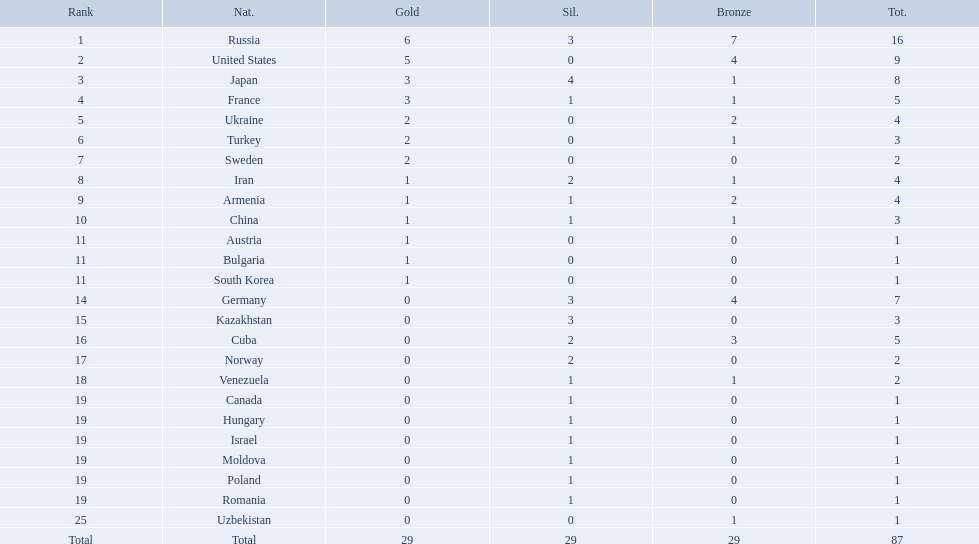Which nations participated in the 1995 world wrestling championships? Russia, United States, Japan, France, Ukraine, Turkey, Sweden, Iran, Armenia, China, Austria, Bulgaria, South Korea, Germany, Kazakhstan, Cuba, Norway, Venezuela, Canada, Hungary, Israel, Moldova, Poland, Romania, Uzbekistan. And between iran and germany, which one placed in the top 10? Germany. How many gold medals did the united states win? 5. Who won more than 5 gold medals? Russia. What were the nations that participated in the 1995 world wrestling championships? Russia, United States, Japan, France, Ukraine, Turkey, Sweden, Iran, Armenia, China, Austria, Bulgaria, South Korea, Germany, Kazakhstan, Cuba, Norway, Venezuela, Canada, Hungary, Israel, Moldova, Poland, Romania, Uzbekistan. How many gold medals did the united states earn in the championship? 5. What amount of medals earner was greater than this value? 6. What country earned these medals? Russia. Which nations are there? Russia, 6, United States, 5, Japan, 3, France, 3, Ukraine, 2, Turkey, 2, Sweden, 2, Iran, 1, Armenia, 1, China, 1, Austria, 1, Bulgaria, 1, South Korea, 1, Germany, 0, Kazakhstan, 0, Cuba, 0, Norway, 0, Venezuela, 0, Canada, 0, Hungary, 0, Israel, 0, Moldova, 0, Poland, 0, Romania, 0, Uzbekistan, 0. Which nations won gold? Russia, 6, United States, 5, Japan, 3, France, 3, Ukraine, 2, Turkey, 2, Sweden, 2, Iran, 1, Armenia, 1, China, 1, Austria, 1, Bulgaria, 1, South Korea, 1. How many golds did united states win? United States, 5. Which country has more than 5 gold medals? Russia, 6. What country is it? Russia. Parse the full table in json format. {'header': ['Rank', 'Nat.', 'Gold', 'Sil.', 'Bronze', 'Tot.'], 'rows': [['1', 'Russia', '6', '3', '7', '16'], ['2', 'United States', '5', '0', '4', '9'], ['3', 'Japan', '3', '4', '1', '8'], ['4', 'France', '3', '1', '1', '5'], ['5', 'Ukraine', '2', '0', '2', '4'], ['6', 'Turkey', '2', '0', '1', '3'], ['7', 'Sweden', '2', '0', '0', '2'], ['8', 'Iran', '1', '2', '1', '4'], ['9', 'Armenia', '1', '1', '2', '4'], ['10', 'China', '1', '1', '1', '3'], ['11', 'Austria', '1', '0', '0', '1'], ['11', 'Bulgaria', '1', '0', '0', '1'], ['11', 'South Korea', '1', '0', '0', '1'], ['14', 'Germany', '0', '3', '4', '7'], ['15', 'Kazakhstan', '0', '3', '0', '3'], ['16', 'Cuba', '0', '2', '3', '5'], ['17', 'Norway', '0', '2', '0', '2'], ['18', 'Venezuela', '0', '1', '1', '2'], ['19', 'Canada', '0', '1', '0', '1'], ['19', 'Hungary', '0', '1', '0', '1'], ['19', 'Israel', '0', '1', '0', '1'], ['19', 'Moldova', '0', '1', '0', '1'], ['19', 'Poland', '0', '1', '0', '1'], ['19', 'Romania', '0', '1', '0', '1'], ['25', 'Uzbekistan', '0', '0', '1', '1'], ['Total', 'Total', '29', '29', '29', '87']]} What nations have one gold medal? Iran, Armenia, China, Austria, Bulgaria, South Korea. Of these, which nations have zero silver medals? Austria, Bulgaria, South Korea. Of these, which nations also have zero bronze medals? Austria. Which nations only won less then 5 medals? Ukraine, Turkey, Sweden, Iran, Armenia, China, Austria, Bulgaria, South Korea, Germany, Kazakhstan, Norway, Venezuela, Canada, Hungary, Israel, Moldova, Poland, Romania, Uzbekistan. Which of these were not asian nations? Ukraine, Turkey, Sweden, Iran, Armenia, Austria, Bulgaria, Germany, Kazakhstan, Norway, Venezuela, Canada, Hungary, Israel, Moldova, Poland, Romania, Uzbekistan. Which of those did not win any silver medals? Ukraine, Turkey, Sweden, Austria, Bulgaria, Uzbekistan. Which ones of these had only one medal total? Austria, Bulgaria, Uzbekistan. Which of those would be listed first alphabetically? Austria. 